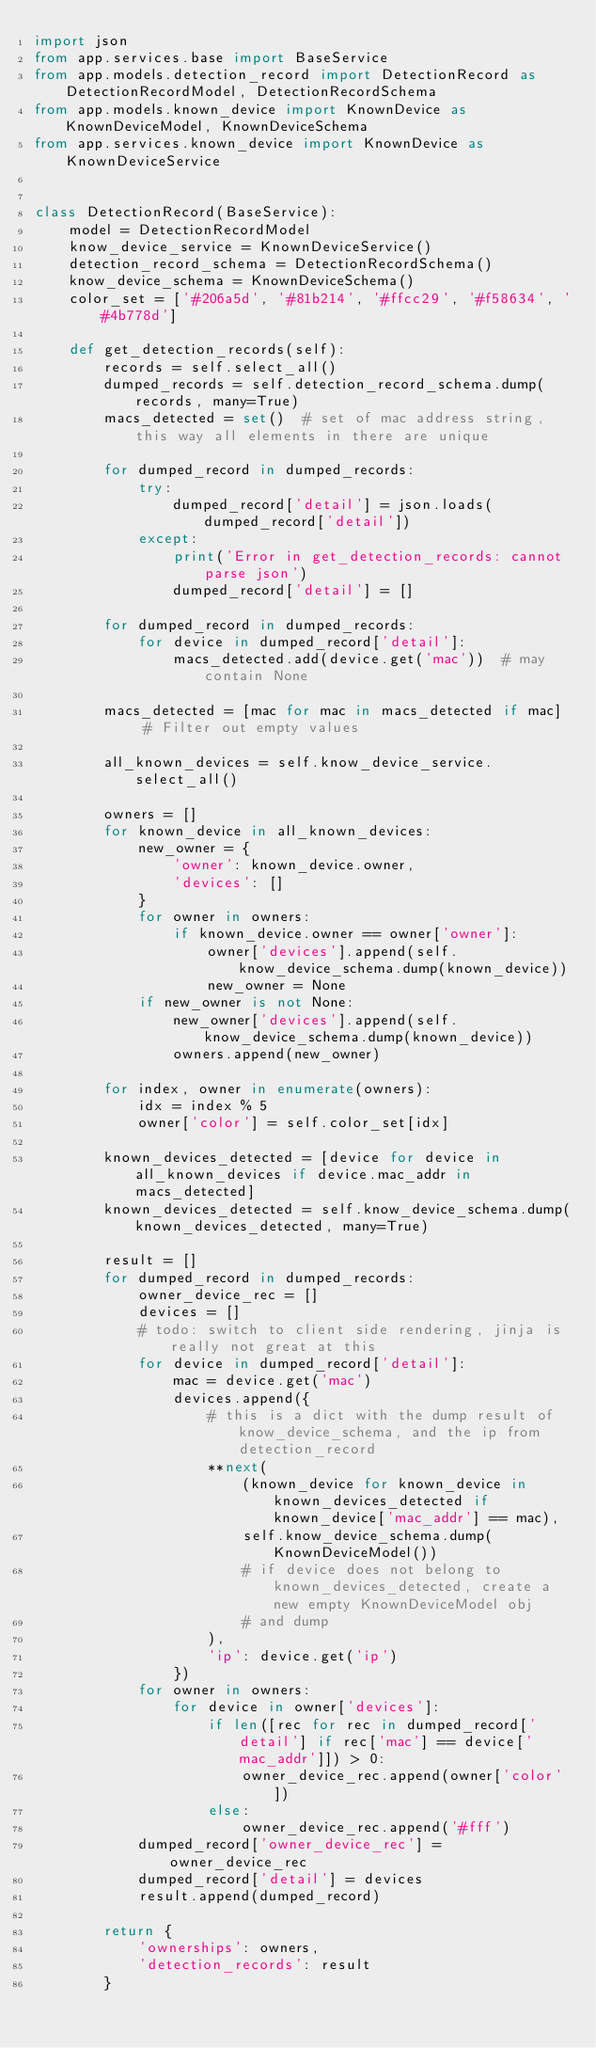Convert code to text. <code><loc_0><loc_0><loc_500><loc_500><_Python_>import json
from app.services.base import BaseService
from app.models.detection_record import DetectionRecord as DetectionRecordModel, DetectionRecordSchema
from app.models.known_device import KnownDevice as KnownDeviceModel, KnownDeviceSchema
from app.services.known_device import KnownDevice as KnownDeviceService


class DetectionRecord(BaseService):
    model = DetectionRecordModel
    know_device_service = KnownDeviceService()
    detection_record_schema = DetectionRecordSchema()
    know_device_schema = KnownDeviceSchema()
    color_set = ['#206a5d', '#81b214', '#ffcc29', '#f58634', '#4b778d']

    def get_detection_records(self):
        records = self.select_all()
        dumped_records = self.detection_record_schema.dump(records, many=True)
        macs_detected = set()  # set of mac address string, this way all elements in there are unique

        for dumped_record in dumped_records:
            try:
                dumped_record['detail'] = json.loads(dumped_record['detail'])
            except:
                print('Error in get_detection_records: cannot parse json')
                dumped_record['detail'] = []

        for dumped_record in dumped_records:
            for device in dumped_record['detail']:
                macs_detected.add(device.get('mac'))  # may contain None

        macs_detected = [mac for mac in macs_detected if mac]  # Filter out empty values

        all_known_devices = self.know_device_service.select_all()

        owners = []
        for known_device in all_known_devices:
            new_owner = {
                'owner': known_device.owner,
                'devices': []
            }
            for owner in owners:
                if known_device.owner == owner['owner']:
                    owner['devices'].append(self.know_device_schema.dump(known_device))
                    new_owner = None
            if new_owner is not None:
                new_owner['devices'].append(self.know_device_schema.dump(known_device))
                owners.append(new_owner)

        for index, owner in enumerate(owners):
            idx = index % 5
            owner['color'] = self.color_set[idx]

        known_devices_detected = [device for device in all_known_devices if device.mac_addr in macs_detected]
        known_devices_detected = self.know_device_schema.dump(known_devices_detected, many=True)

        result = []
        for dumped_record in dumped_records:
            owner_device_rec = []
            devices = []
            # todo: switch to client side rendering, jinja is really not great at this
            for device in dumped_record['detail']:
                mac = device.get('mac')
                devices.append({
                    # this is a dict with the dump result of know_device_schema, and the ip from detection_record
                    **next(
                        (known_device for known_device in known_devices_detected if known_device['mac_addr'] == mac),
                        self.know_device_schema.dump(KnownDeviceModel())
                        # if device does not belong to known_devices_detected, create a new empty KnownDeviceModel obj
                        # and dump
                    ),
                    'ip': device.get('ip')
                })
            for owner in owners:
                for device in owner['devices']:
                    if len([rec for rec in dumped_record['detail'] if rec['mac'] == device['mac_addr']]) > 0:
                        owner_device_rec.append(owner['color'])
                    else:
                        owner_device_rec.append('#fff')
            dumped_record['owner_device_rec'] = owner_device_rec
            dumped_record['detail'] = devices
            result.append(dumped_record)

        return {
            'ownerships': owners,
            'detection_records': result
        }
</code> 